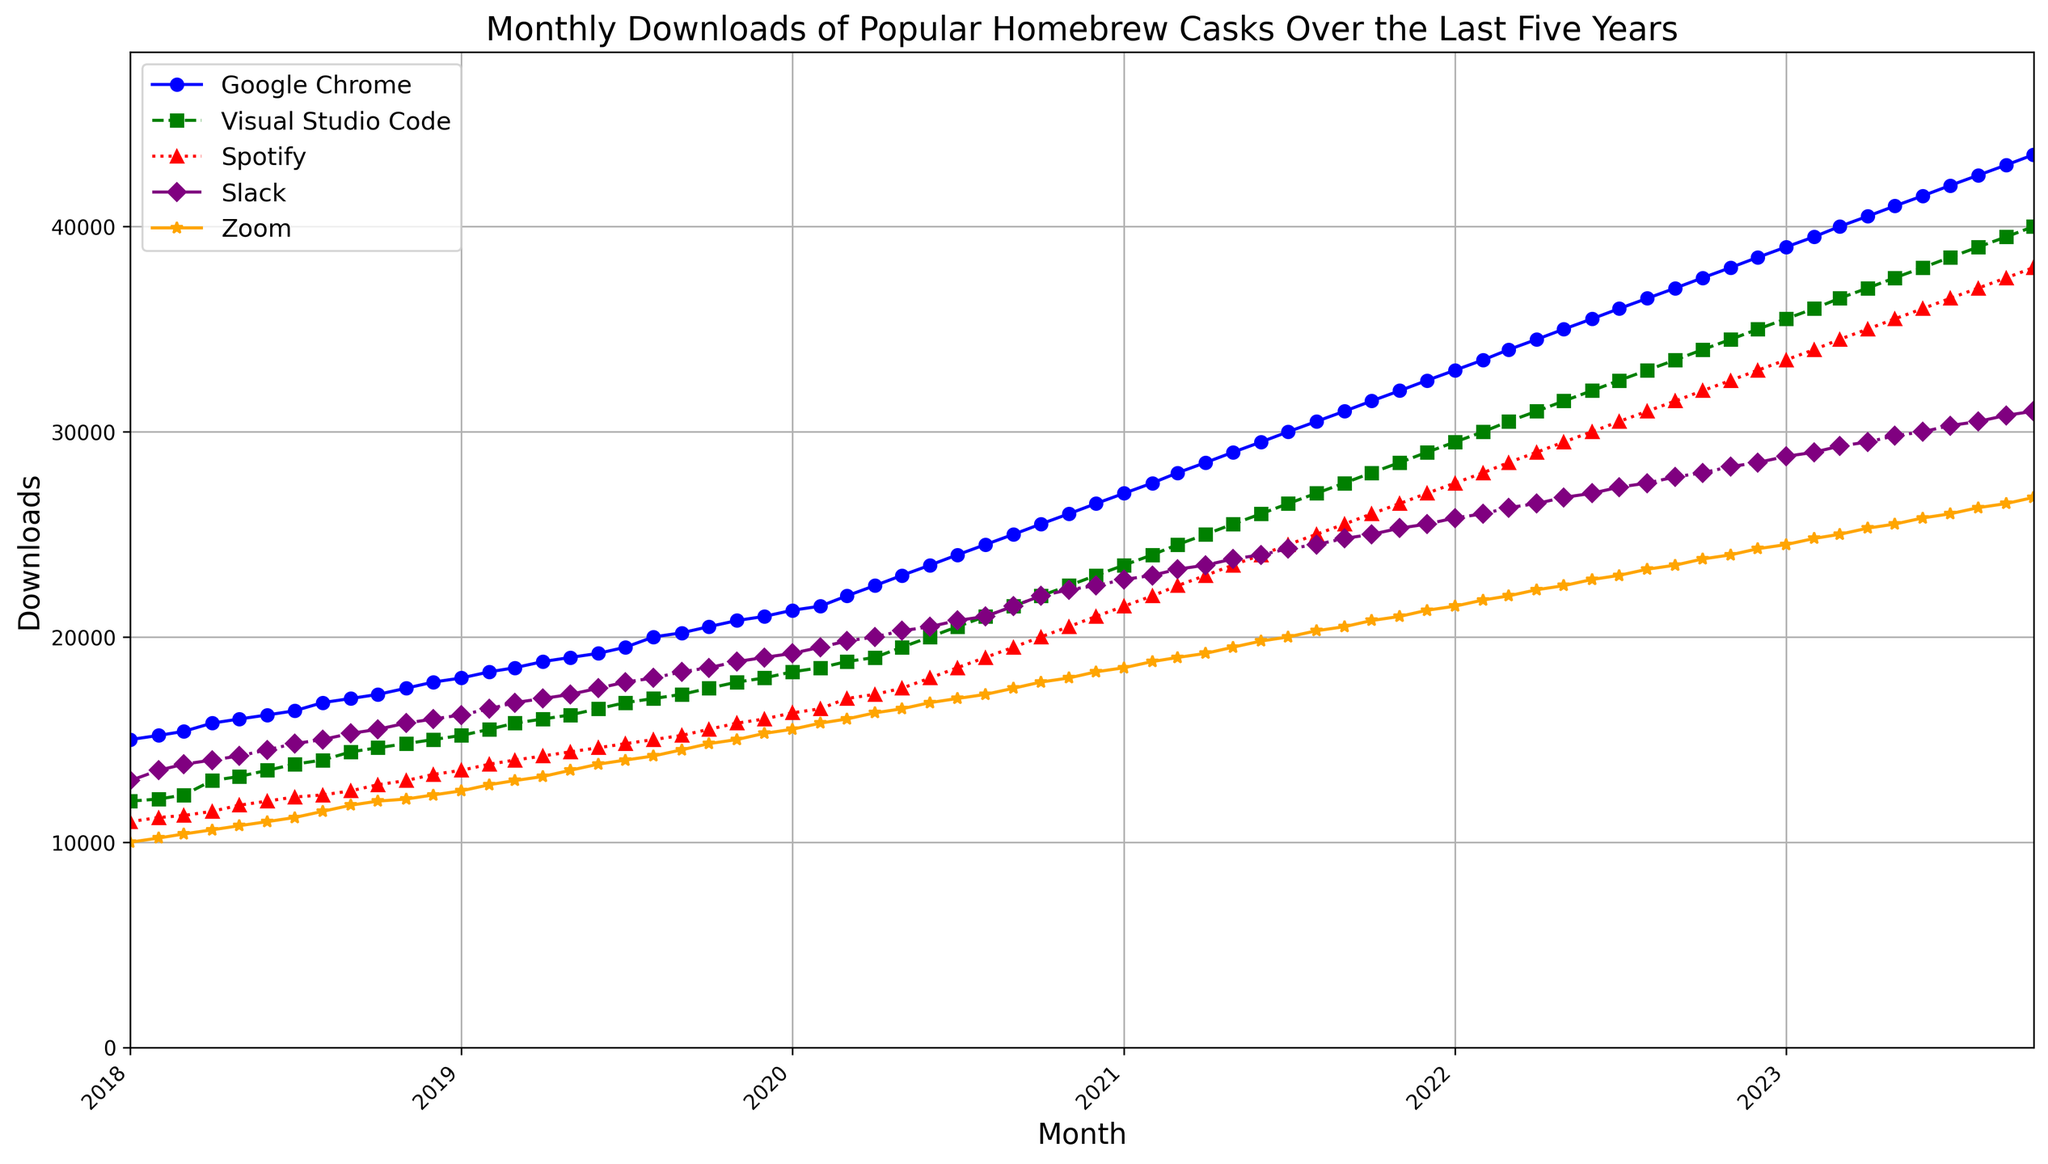What is the overall trend for the downloads of Google Chrome from 2018 to 2023? Observing the blue line representing Google Chrome, it shows a consistent upward trend from 2018 to 2023.
Answer: Consistent increase Which cask had the highest number of downloads in January 2021? January 2021 corresponds to the data points at the beginning of 2021. Checking the y-values for each line at this time, the blue line (Google Chrome) is at the highest point.
Answer: Google Chrome Has the download rate of Visual Studio Code increased faster than Slack in the last two years? From the start of 2021 to the end of the plot in 2023, Visual Studio Code (green line) shows an increase from around 23500 to 40000 downloads, and Slack (purple line) shows an increase from around 22800 to 31000 downloads. Visual Studio Code increased by 16500, while Slack increased by 8200.
Answer: Yes Which month in 2023 saw the highest downloads for Zoom, and how many were downloaded? For Zoom (orange line), the highest point in 2023 occurs in October, with the y-value corresponding to around 26800 downloads.
Answer: October 2023, 26800 downloads During which period did Spotify see the fastest growth in the number of downloads, and how can you identify it? The fastest growth for Spotify (red line) can be identified by the steepest incline. This occurs from late 2019 to early 2021, where the slope of the line increases sharply.
Answer: Late 2019 to early 2021 Between January 2018 and December 2019, which cask had the most downloads overall? Summing the areas under the respective curves from January 2018 to December 2019 shows that Google Chrome (blue line) consistently stayed the highest above others during this period.
Answer: Google Chrome How do the download patterns of Slack compare visually to those of Visual Studio Code? The purple line (Slack) initially follows a closely rising pattern like the green line (Visual Studio Code), but there are periods where Slack's increases appear more gradual and, at times, stagnant compared to Visual Studio Code's consistent pace of growth.
Answer: Slack's increases are more gradual Was there ever a point when Spotify downloads surpassed Visual Studio Code downloads? Based on the plot data, the red line (Spotify) never crosses above the green line (Visual Studio Code); thus, Spotify downloads were always below Visual Studio Code's.
Answer: No On average, how much did Google Chrome download numbers increase per month from 2018 to 2020? Google Chrome increased from 15000 to 26500 downloads over 36 months. The average monthly increase is (26500 - 15000) / 36.
Answer: 319.44 downloads Which month saw the steepest increase in Zoom downloads in 2020, and what visual indicates this? The steepest increase is indicated by the sharpest incline in the orange line for Zoom. This occurs between March and April 2020.
Answer: April 2020 